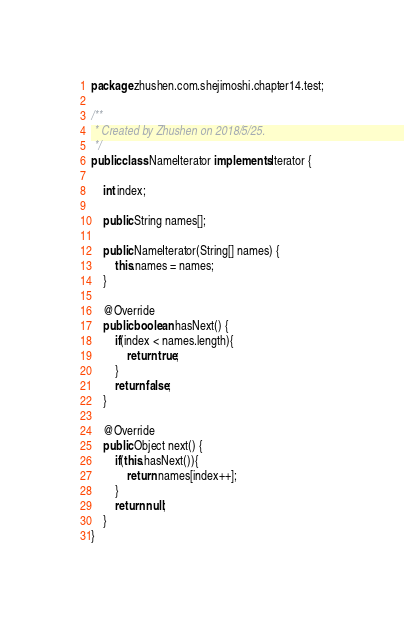<code> <loc_0><loc_0><loc_500><loc_500><_Java_>package zhushen.com.shejimoshi.chapter14.test;

/**
 * Created by Zhushen on 2018/5/25.
 */
public class NameIterator implements Iterator {

    int index;

    public String names[];

    public NameIterator(String[] names) {
        this.names = names;
    }

    @Override
    public boolean hasNext() {
        if(index < names.length){
            return true;
        }
        return false;
    }

    @Override
    public Object next() {
        if(this.hasNext()){
            return names[index++];
        }
        return null;
    }
}
</code> 